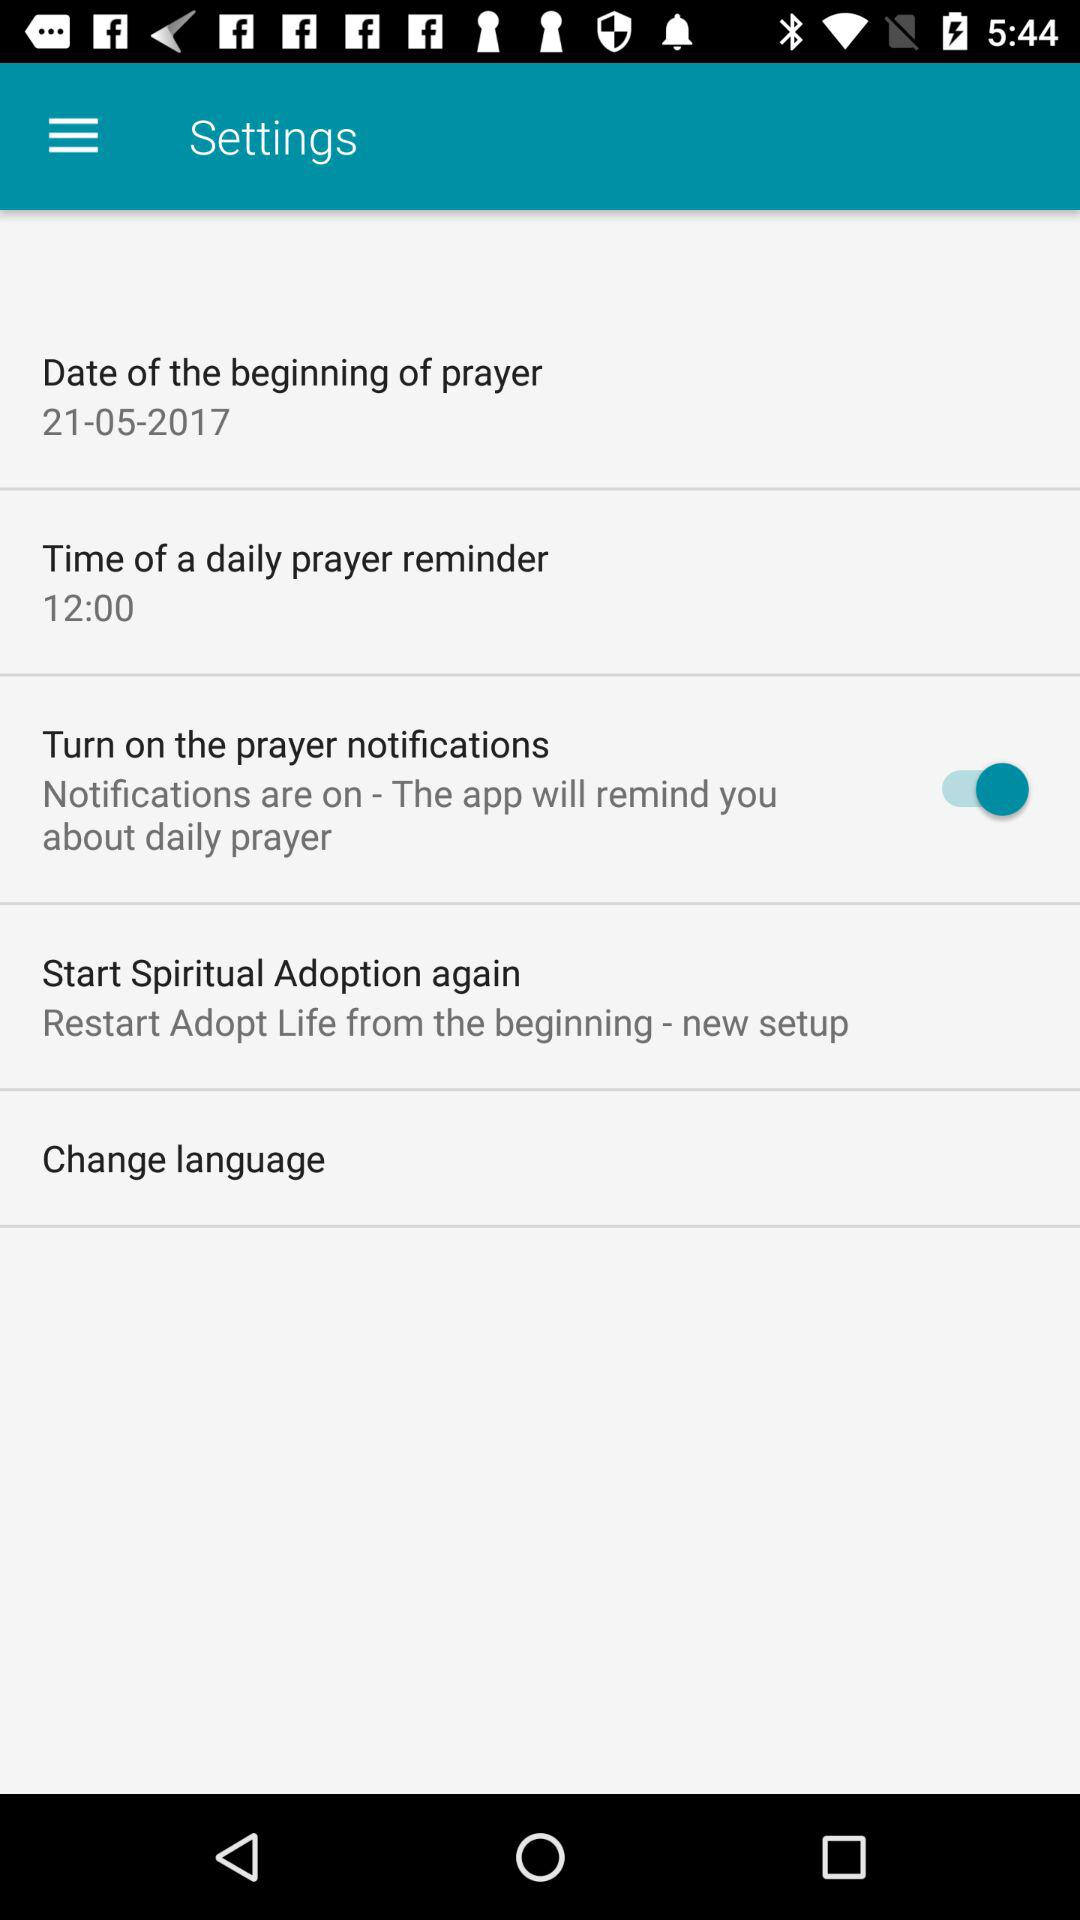What is the date of the beginning of prayer? The date of the beginning of prayer is May 21, 2017. 